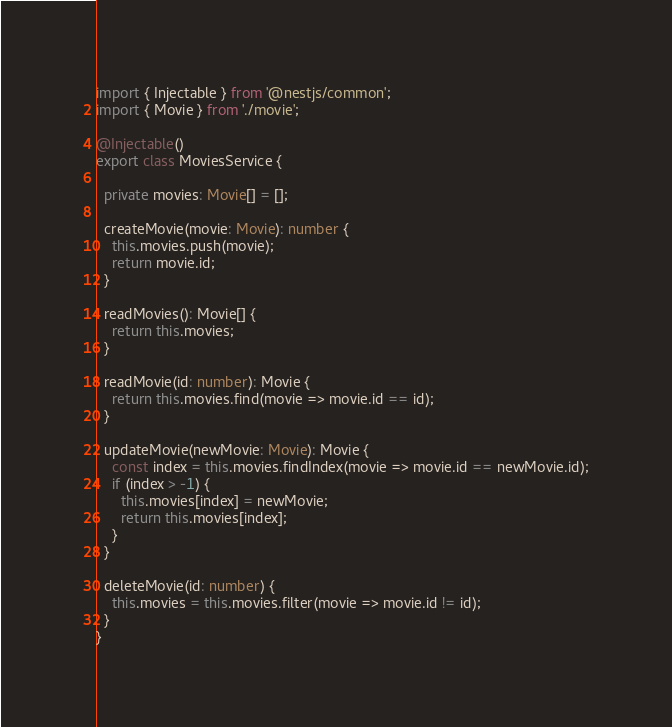Convert code to text. <code><loc_0><loc_0><loc_500><loc_500><_TypeScript_>import { Injectable } from '@nestjs/common';
import { Movie } from './movie';

@Injectable()
export class MoviesService {

  private movies: Movie[] = [];

  createMovie(movie: Movie): number {
    this.movies.push(movie);
    return movie.id;
  }

  readMovies(): Movie[] {
    return this.movies;
  }

  readMovie(id: number): Movie {
    return this.movies.find(movie => movie.id == id);
  }

  updateMovie(newMovie: Movie): Movie {
    const index = this.movies.findIndex(movie => movie.id == newMovie.id);
    if (index > -1) {
      this.movies[index] = newMovie;
      return this.movies[index];
    }
  }

  deleteMovie(id: number) {
    this.movies = this.movies.filter(movie => movie.id != id);
  }
}
</code> 